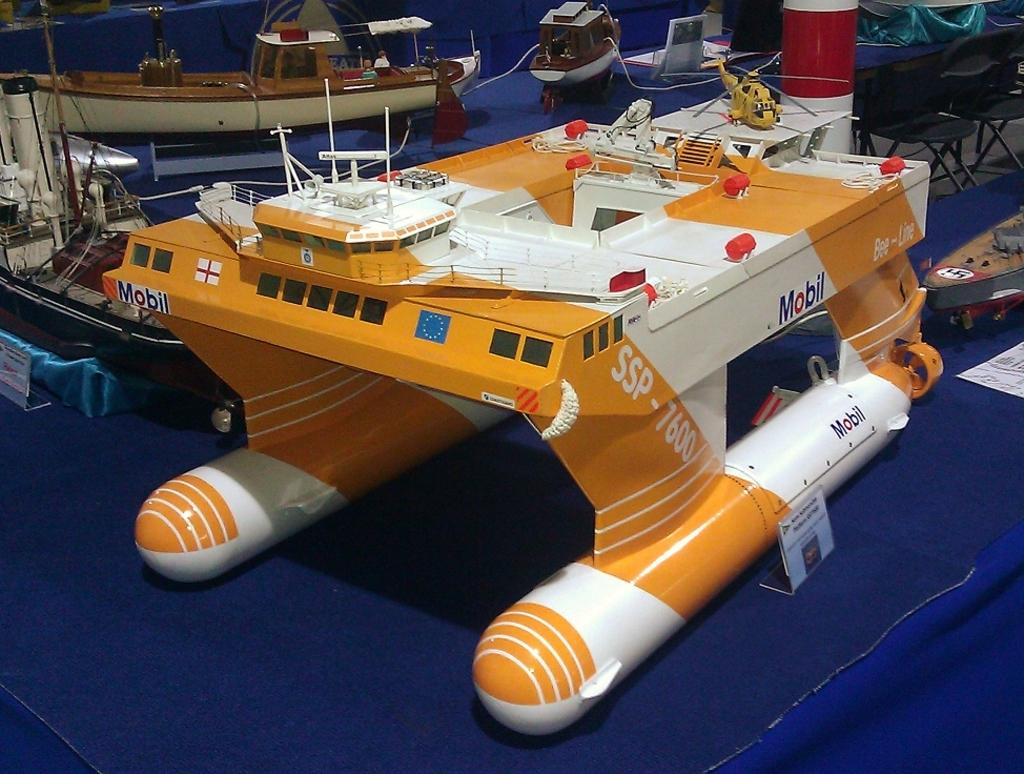What type of model is depicted in the image? The image is a scale model. What can be seen in the scale model? There are boats in the scale model. Are there any other objects or features present in the scale model besides the boats? Yes, there are other things present in the scale model. How many sisters are depicted in the scale model? There are no sisters present in the scale model; it features boats and other unspecified objects or features. 